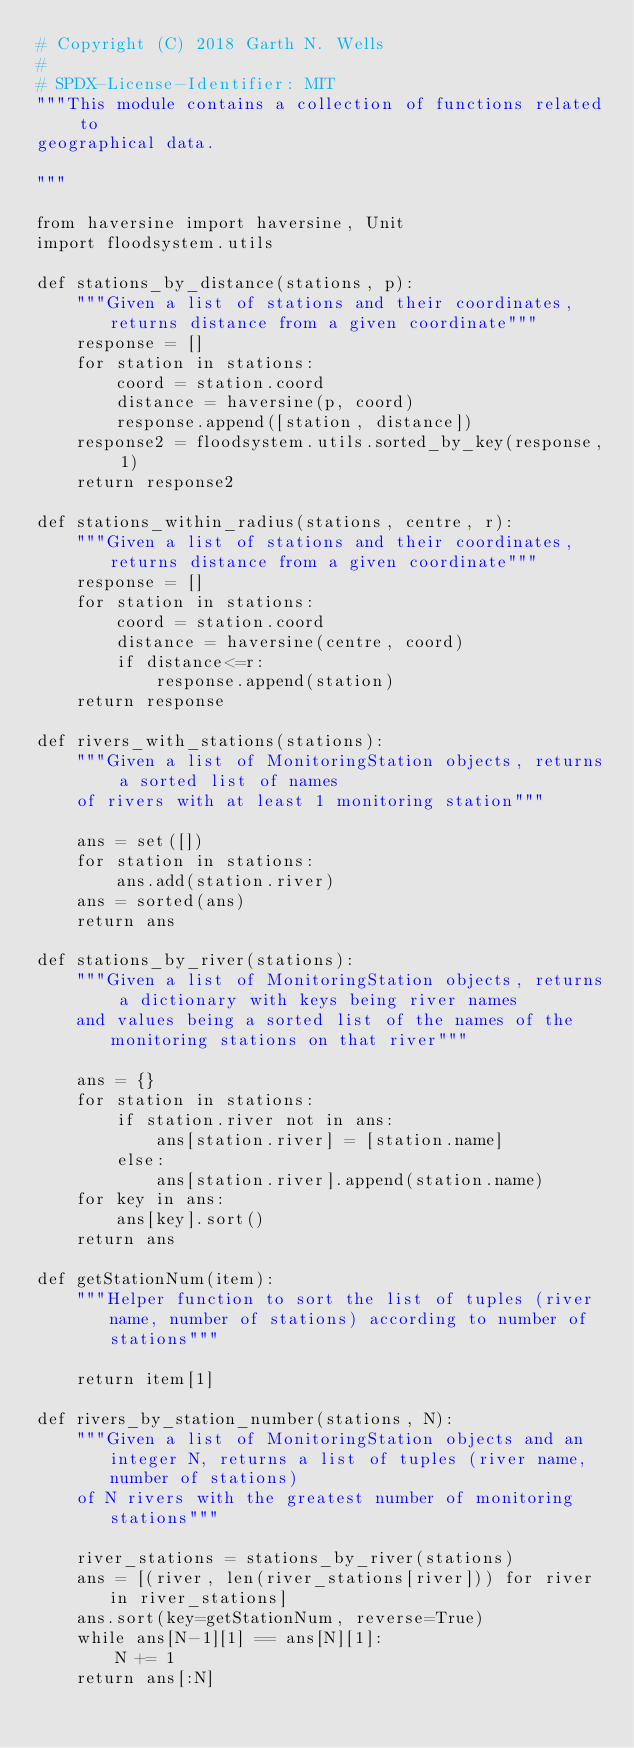Convert code to text. <code><loc_0><loc_0><loc_500><loc_500><_Python_># Copyright (C) 2018 Garth N. Wells
#
# SPDX-License-Identifier: MIT
"""This module contains a collection of functions related to
geographical data.

"""

from haversine import haversine, Unit
import floodsystem.utils

def stations_by_distance(stations, p):
    """Given a list of stations and their coordinates, returns distance from a given coordinate"""
    response = []
    for station in stations:
        coord = station.coord
        distance = haversine(p, coord)
        response.append([station, distance])
    response2 = floodsystem.utils.sorted_by_key(response, 1)
    return response2

def stations_within_radius(stations, centre, r):
    """Given a list of stations and their coordinates, returns distance from a given coordinate"""
    response = []
    for station in stations:
        coord = station.coord
        distance = haversine(centre, coord)
        if distance<=r:
            response.append(station)
    return response

def rivers_with_stations(stations): 
    """Given a list of MonitoringStation objects, returns a sorted list of names 
    of rivers with at least 1 monitoring station"""

    ans = set([])
    for station in stations: 
        ans.add(station.river)
    ans = sorted(ans)
    return ans

def stations_by_river(stations): 
    """Given a list of MonitoringStation objects, returns a dictionary with keys being river names
    and values being a sorted list of the names of the monitoring stations on that river"""

    ans = {}
    for station in stations: 
        if station.river not in ans: 
            ans[station.river] = [station.name]
        else: 
            ans[station.river].append(station.name)
    for key in ans: 
        ans[key].sort()
    return ans

def getStationNum(item): 
    """Helper function to sort the list of tuples (river name, number of stations) according to number of stations"""
    
    return item[1]

def rivers_by_station_number(stations, N): 
    """Given a list of MonitoringStation objects and an integer N, returns a list of tuples (river name, number of stations)
    of N rivers with the greatest number of monitoring stations"""

    river_stations = stations_by_river(stations)
    ans = [(river, len(river_stations[river])) for river in river_stations]
    ans.sort(key=getStationNum, reverse=True)
    while ans[N-1][1] == ans[N][1]: 
        N += 1
    return ans[:N]
</code> 